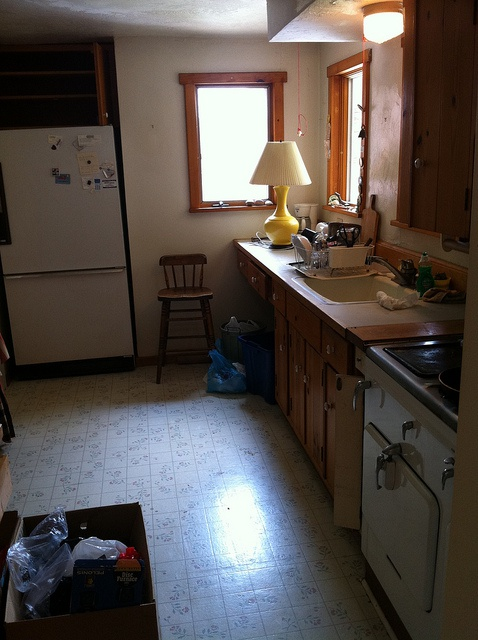Describe the objects in this image and their specific colors. I can see oven in black and gray tones, refrigerator in black and gray tones, chair in black, maroon, and brown tones, sink in black, maroon, darkgray, and gray tones, and bottle in black, maroon, and gray tones in this image. 